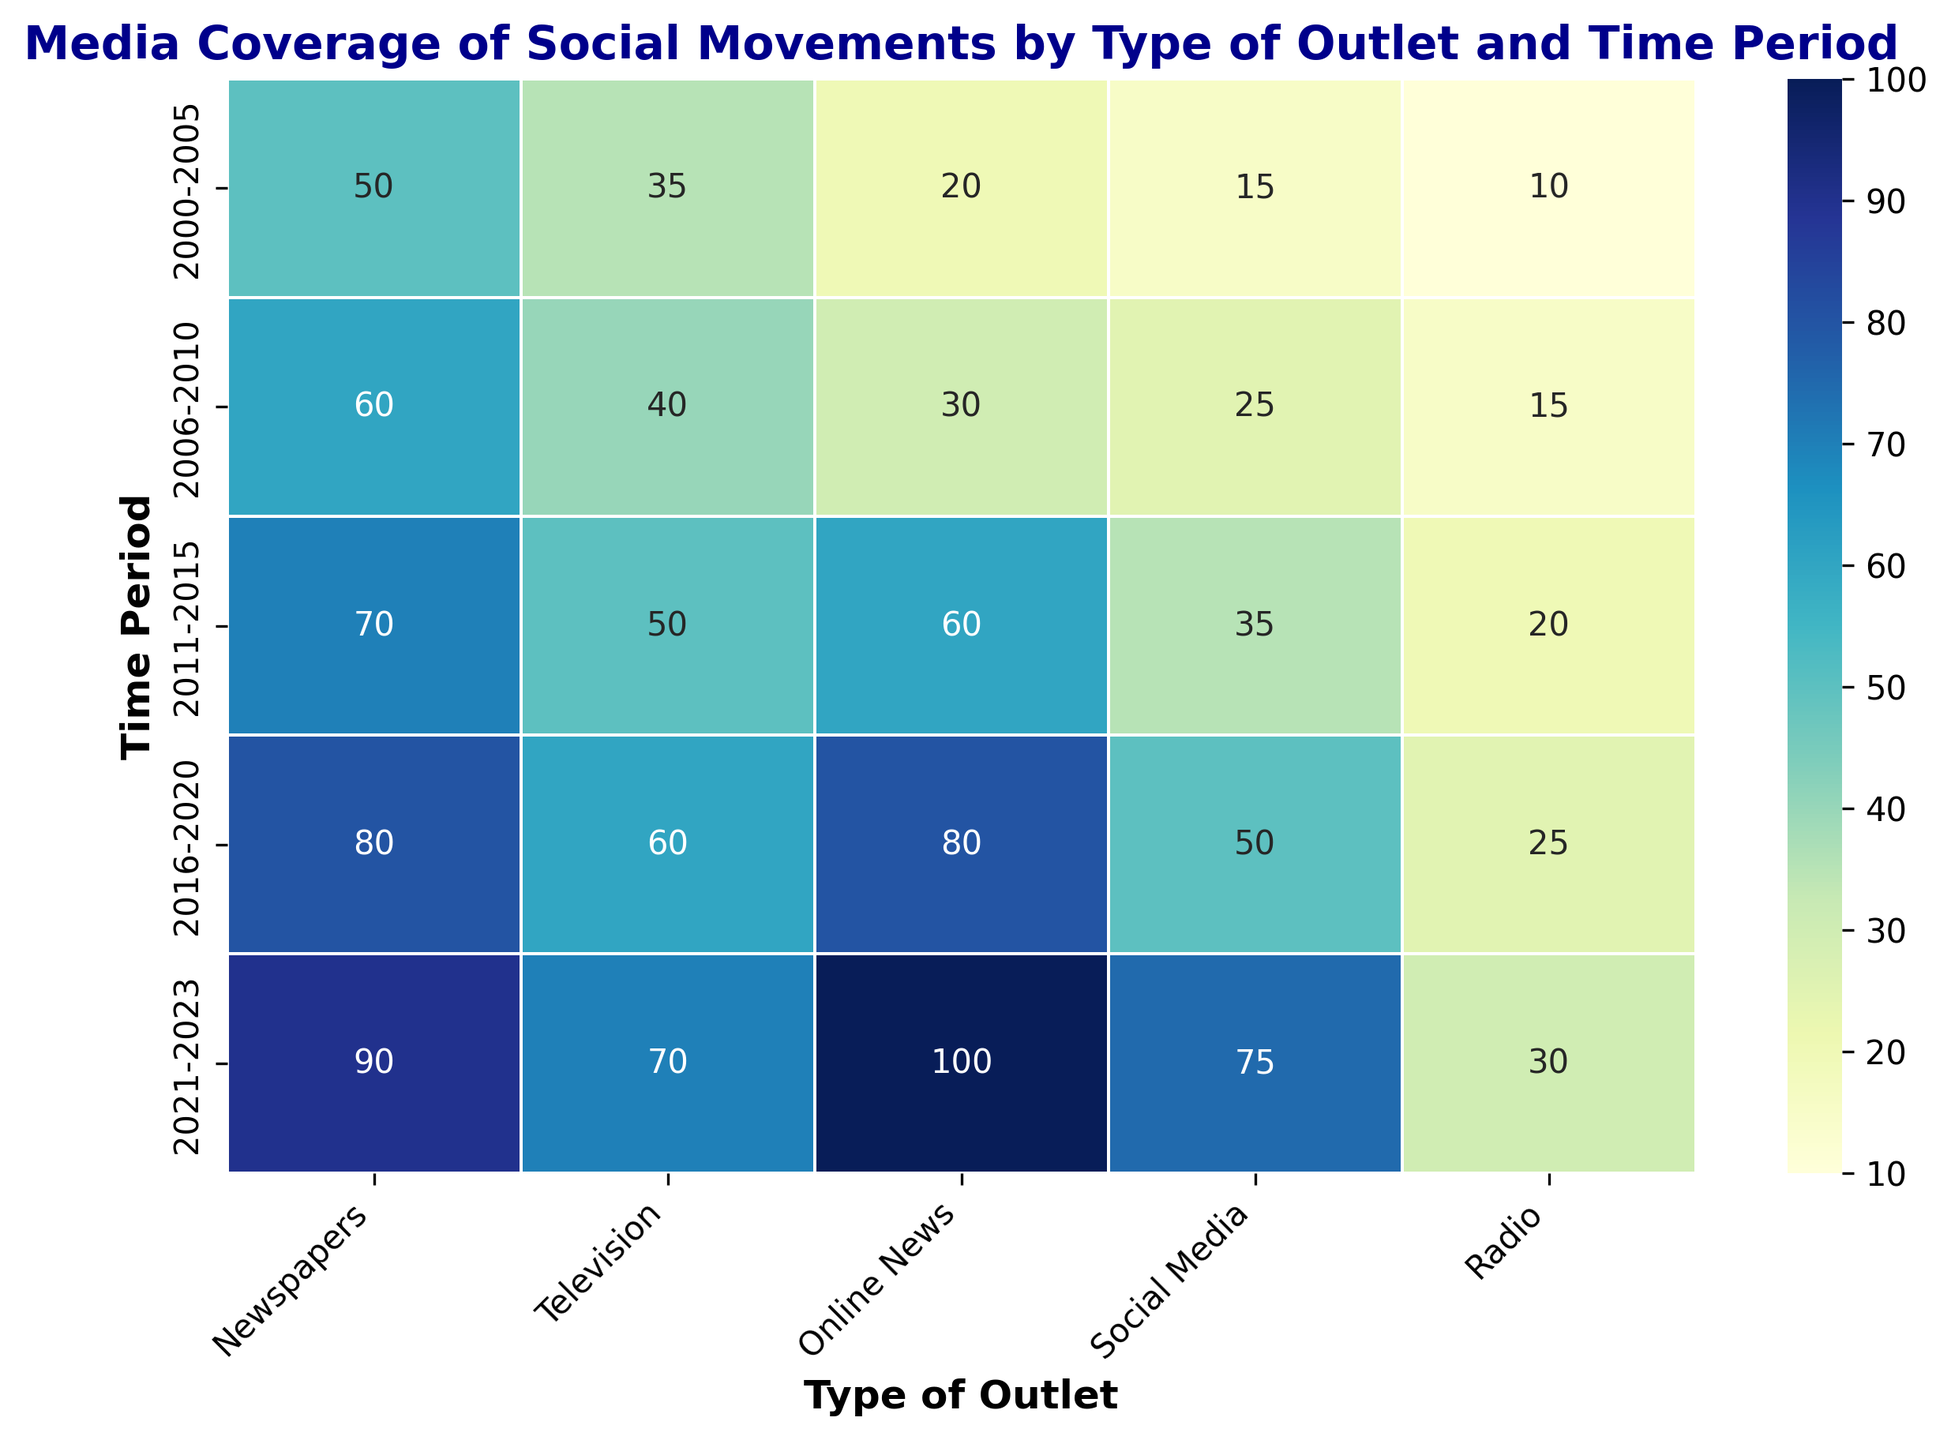What's the total media coverage for social movements in the period 2021-2023 across all types of outlets? Add the coverage values for all types of outlets in the period 2021-2023: Newspapers (90) + Television (70) + Online News (100) + Social Media (75) + Radio (30). Adding these values together gives 90 + 70 + 100 + 75 + 30 = 365.
Answer: 365 Which time period saw the highest media coverage through online news? Look at the column for Online News and identify the time period with the highest coverage. The values are 20, 30, 60, 80, and 100. The highest value is 100, which corresponds to the period 2021-2023.
Answer: 2021-2023 By how much did social media coverage increase from the period 2000-2005 to 2021-2023? Subtract the social media coverage in 2000-2005 (15) from the social media coverage in 2021-2023 (75). The calculation is 75 - 15 = 60.
Answer: 60 What is the average media coverage across all types of outlets for the period 2011-2015? Add the coverage values for 2011-2015 (Newspapers: 70, Television: 50, Online News: 60, Social Media: 35, Radio: 20) and divide by the number of outlets (5). The sum is 70 + 50 + 60 + 35 + 20 = 235. Then calculate the average: 235 / 5 = 47.
Answer: 47 Compare social media coverage in 2006-2010 and 2016-2020. Which period had higher coverage and by how much? Look at the social media column for the periods 2006-2010 (25) and 2016-2020 (50). Subtract the coverage in 2006-2010 from the coverage in 2016-2020: 50 - 25 = 25. The period 2016-2020 had higher coverage by 25.
Answer: 2016-2020 by 25 Which type of outlet saw the smallest increase in media coverage from the period 2000-2005 to 2021-2023? Calculate the increase for each outlet. Newspapers: 90 - 50 = 40, Television: 70 - 35 = 35, Online News: 100 - 20 = 80, Social Media: 75 - 15 = 60, Radio: 30 - 10 = 20. The smallest increase is in Radio, which is an increase of 20.
Answer: Radio What is the total media coverage through radio across all time periods? Add the coverage values for radio in each period: 10 (2000-2005) + 15 (2006-2010) + 20 (2011-2015) + 25 (2016-2020) + 30 (2021-2023). The sum is 10 + 15 + 20 + 25 + 30 = 100.
Answer: 100 Which type of outlet had the largest increase in coverage from the period 2000-2005 to 2021-2023? Calculate the increase for each outlet. Newspapers: 90 - 50 = 40, Television: 70 - 35 = 35, Online News: 100 - 20 = 80, Social Media: 75 - 15 = 60, Radio: 30 - 10 = 20. The largest increase is in Online News, which increased by 80.
Answer: Online News 